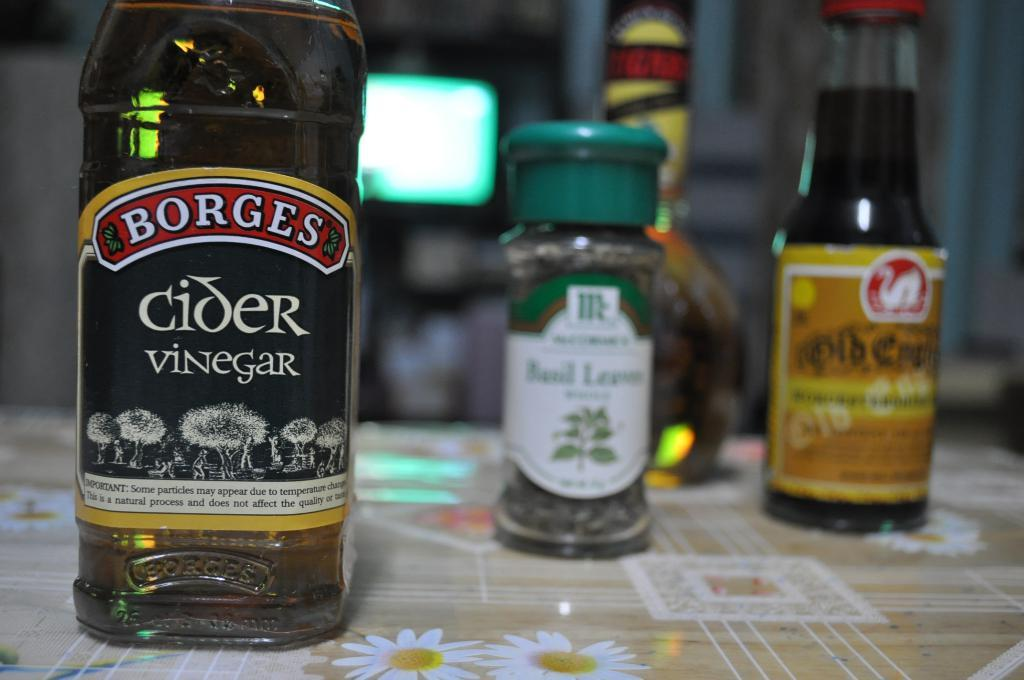<image>
Relay a brief, clear account of the picture shown. A bottle of Borges Cider Vinegar sitting on a table with other spices and liquids in the background. 